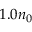<formula> <loc_0><loc_0><loc_500><loc_500>1 . 0 n _ { 0 }</formula> 